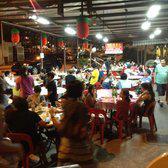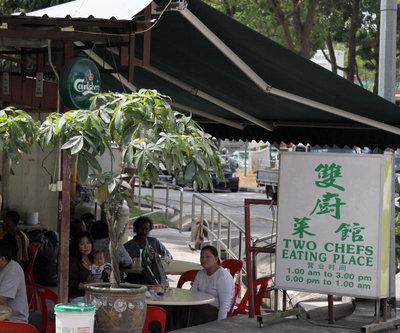The first image is the image on the left, the second image is the image on the right. Given the left and right images, does the statement "IN at least one image there is greenery next to an outside cafe." hold true? Answer yes or no. Yes. The first image is the image on the left, the second image is the image on the right. Evaluate the accuracy of this statement regarding the images: "An image shows a diner with green Chinese characters on a black rectangle at the top front, and a row of lighted horizontal rectangles above a diamond-tile pattern in the background.". Is it true? Answer yes or no. No. 